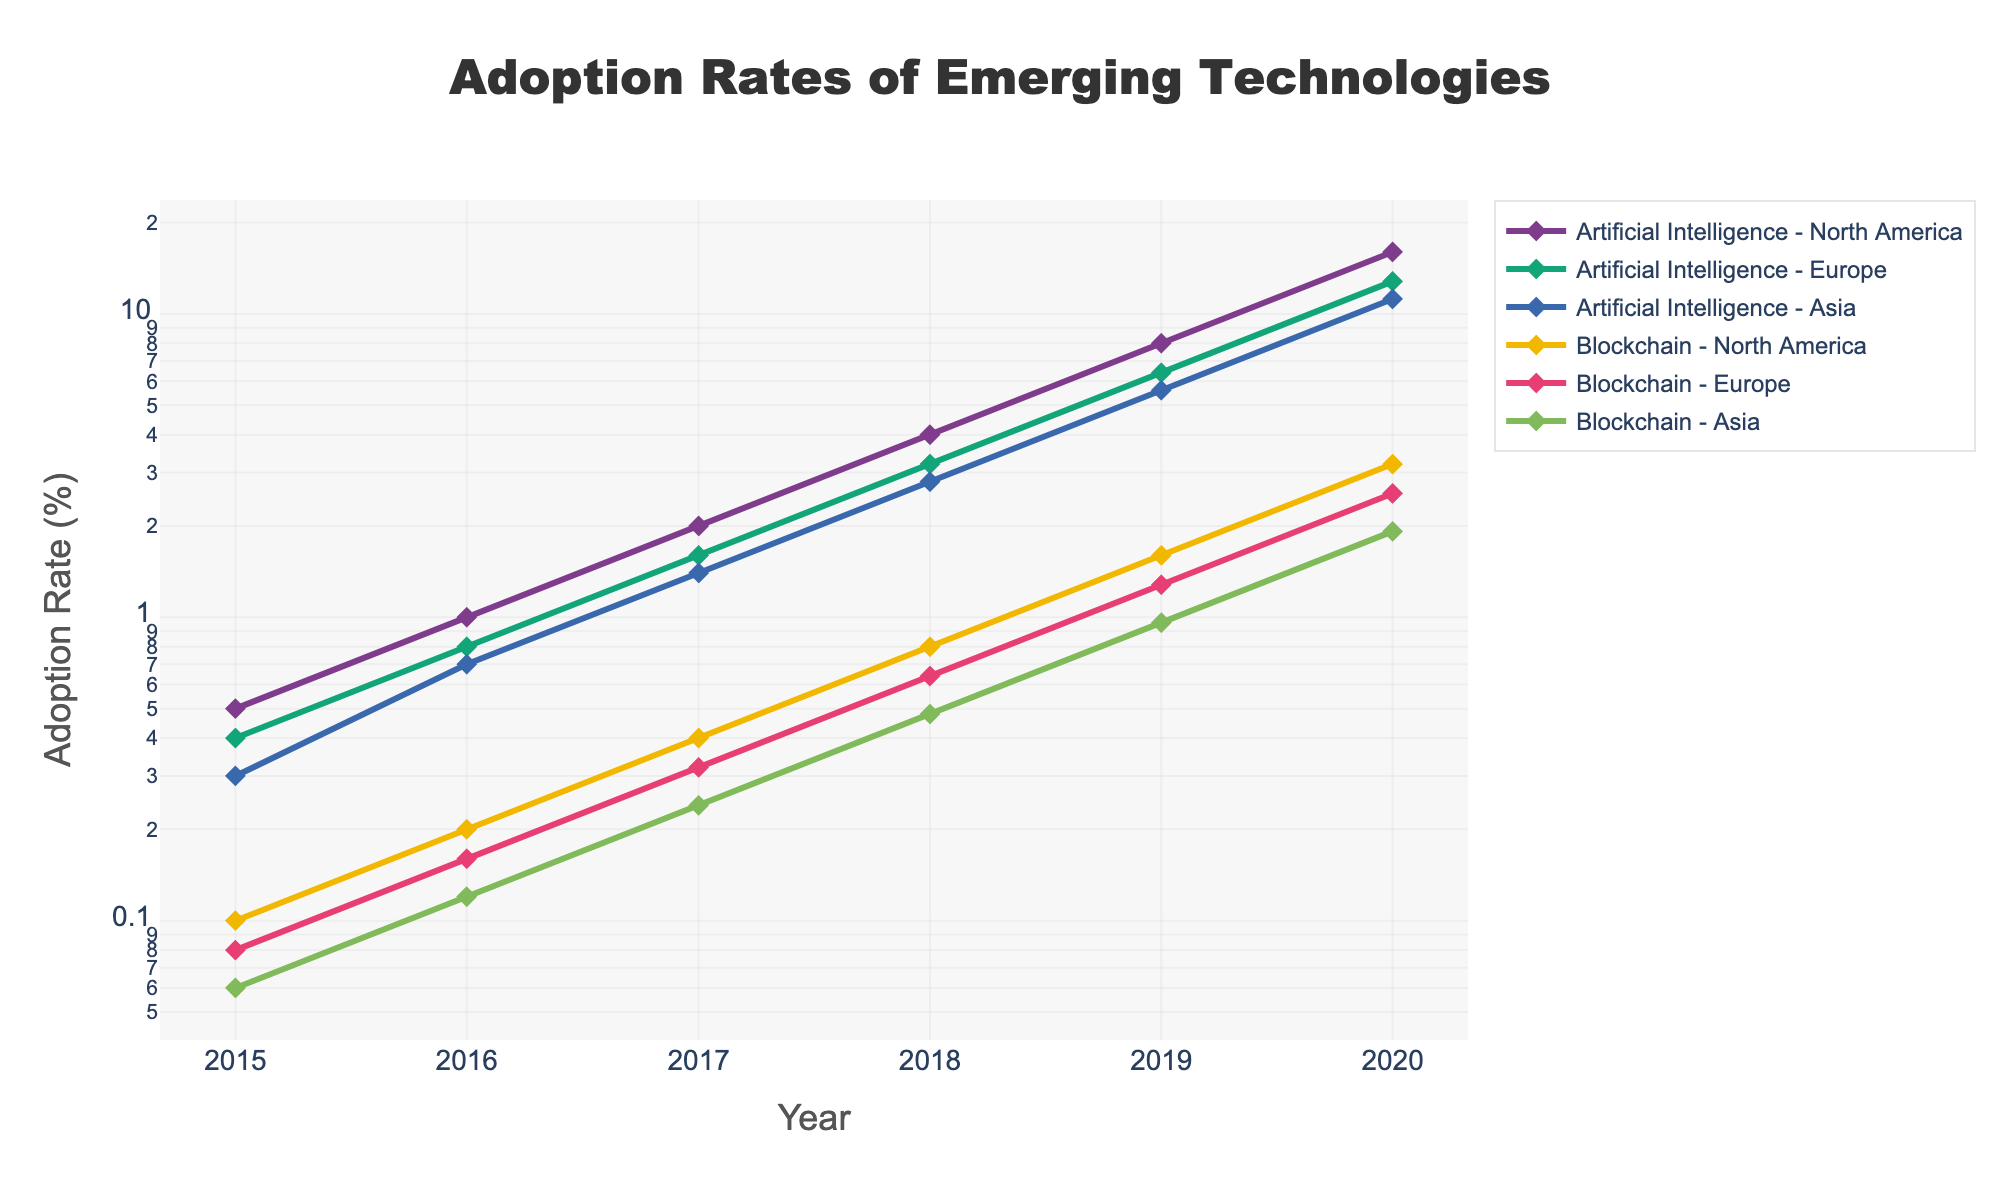What is the title of the figure? The title is usually found at the top of the figure. Here, the title is centered and reads "Adoption Rates of Emerging Technologies".
Answer: Adoption Rates of Emerging Technologies Which region shows the highest adoption rate for Artificial Intelligence in 2020? To answer this, look at the data points for the year 2020 for Artificial Intelligence and compare the adoption rates across North America, Europe, and Asia. North America has the highest adoption rate.
Answer: North America What is the adoption rate of Blockchain in Europe in 2015? Find the data point for Blockchain in 2015 under Europe. The figure shows the adoption rate as 0.08%.
Answer: 0.08% Between 2018 and 2019, which region experienced the greatest increase in adoption rate for Blockchain? Compare the adoption rates for each region in 2018 and 2019, then calculate the difference for each region. North America had an increase from 0.8 to 1.6, Europe from 0.64 to 1.28, and Asia from 0.48 to 0.96. North America shows the greatest increase of 0.8%.
Answer: North America How does the adoption rate of Artificial Intelligence in Asia in 2020 compare to Europe in 2018? Look at the data points for Asia in 2020 and Europe in 2018 for Artificial Intelligence. The adoption rate in Asia in 2020 is 11.2%, and in Europe in 2018 it is 3.2%.
Answer: Asia’s rate is higher What’s the average adoption rate of Artificial Intelligence in North America from 2015 to 2020? Add the adoption rates from 2015 to 2020 (0.5+1.0+2.0+4.0+8.0+16.0) and divide by the number of years (6). (0.5+1.0+2.0+4.0+8.0+16.0)/6 = 5.92
Answer: 5.92 Which technology shows exponential growth across all regions from 2015 to 2020? Examine the trend lines for both technologies. Both show exponential growth, but Artificial Intelligence has a steeper curve indicating stronger exponential growth.
Answer: Artificial Intelligence Is the adoption rate of Blockchain in North America higher or lower than in Asia in 2019? Compare the data points for Blockchain in North America and Asia in 2019. North America's rate is 1.6%, while Asia's rate is 0.96%.
Answer: Higher What was the adoption rate of Artificial Intelligence in Europe in 2019? Locate the data point for Artificial Intelligence in Europe in 2019. The adoption rate is 6.4%.
Answer: 6.4% Between 2015 and 2020, which region had the lowest overall adoption rate for Blockchain? Compare the adoption rates for Blockchain across all regions over the years. Asia consistently shows the lowest rates each year.
Answer: Asia 